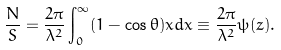Convert formula to latex. <formula><loc_0><loc_0><loc_500><loc_500>\frac { N } { S } = \frac { 2 \pi } { \lambda ^ { 2 } } \int _ { 0 } ^ { \infty } ( 1 - \cos \theta ) x d x \equiv \frac { 2 \pi } { \lambda ^ { 2 } } \psi ( z ) .</formula> 